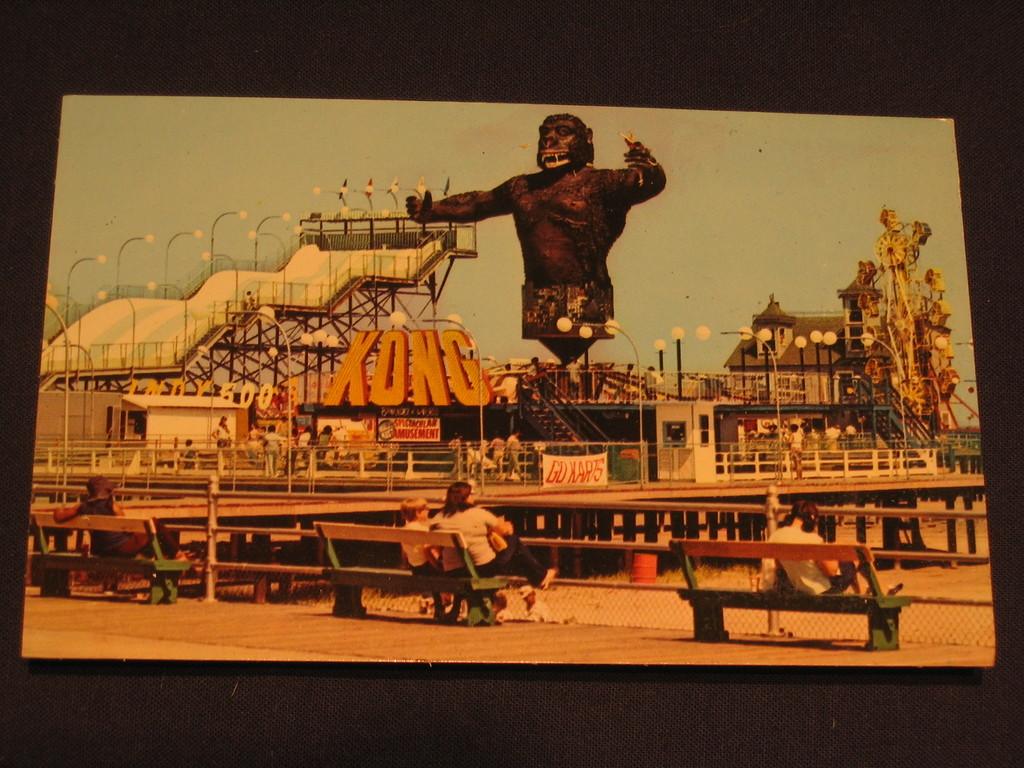Isthis a library exit?
Your answer should be compact. No. What is wrote in big letters beside the animal?
Keep it short and to the point. Kong. 